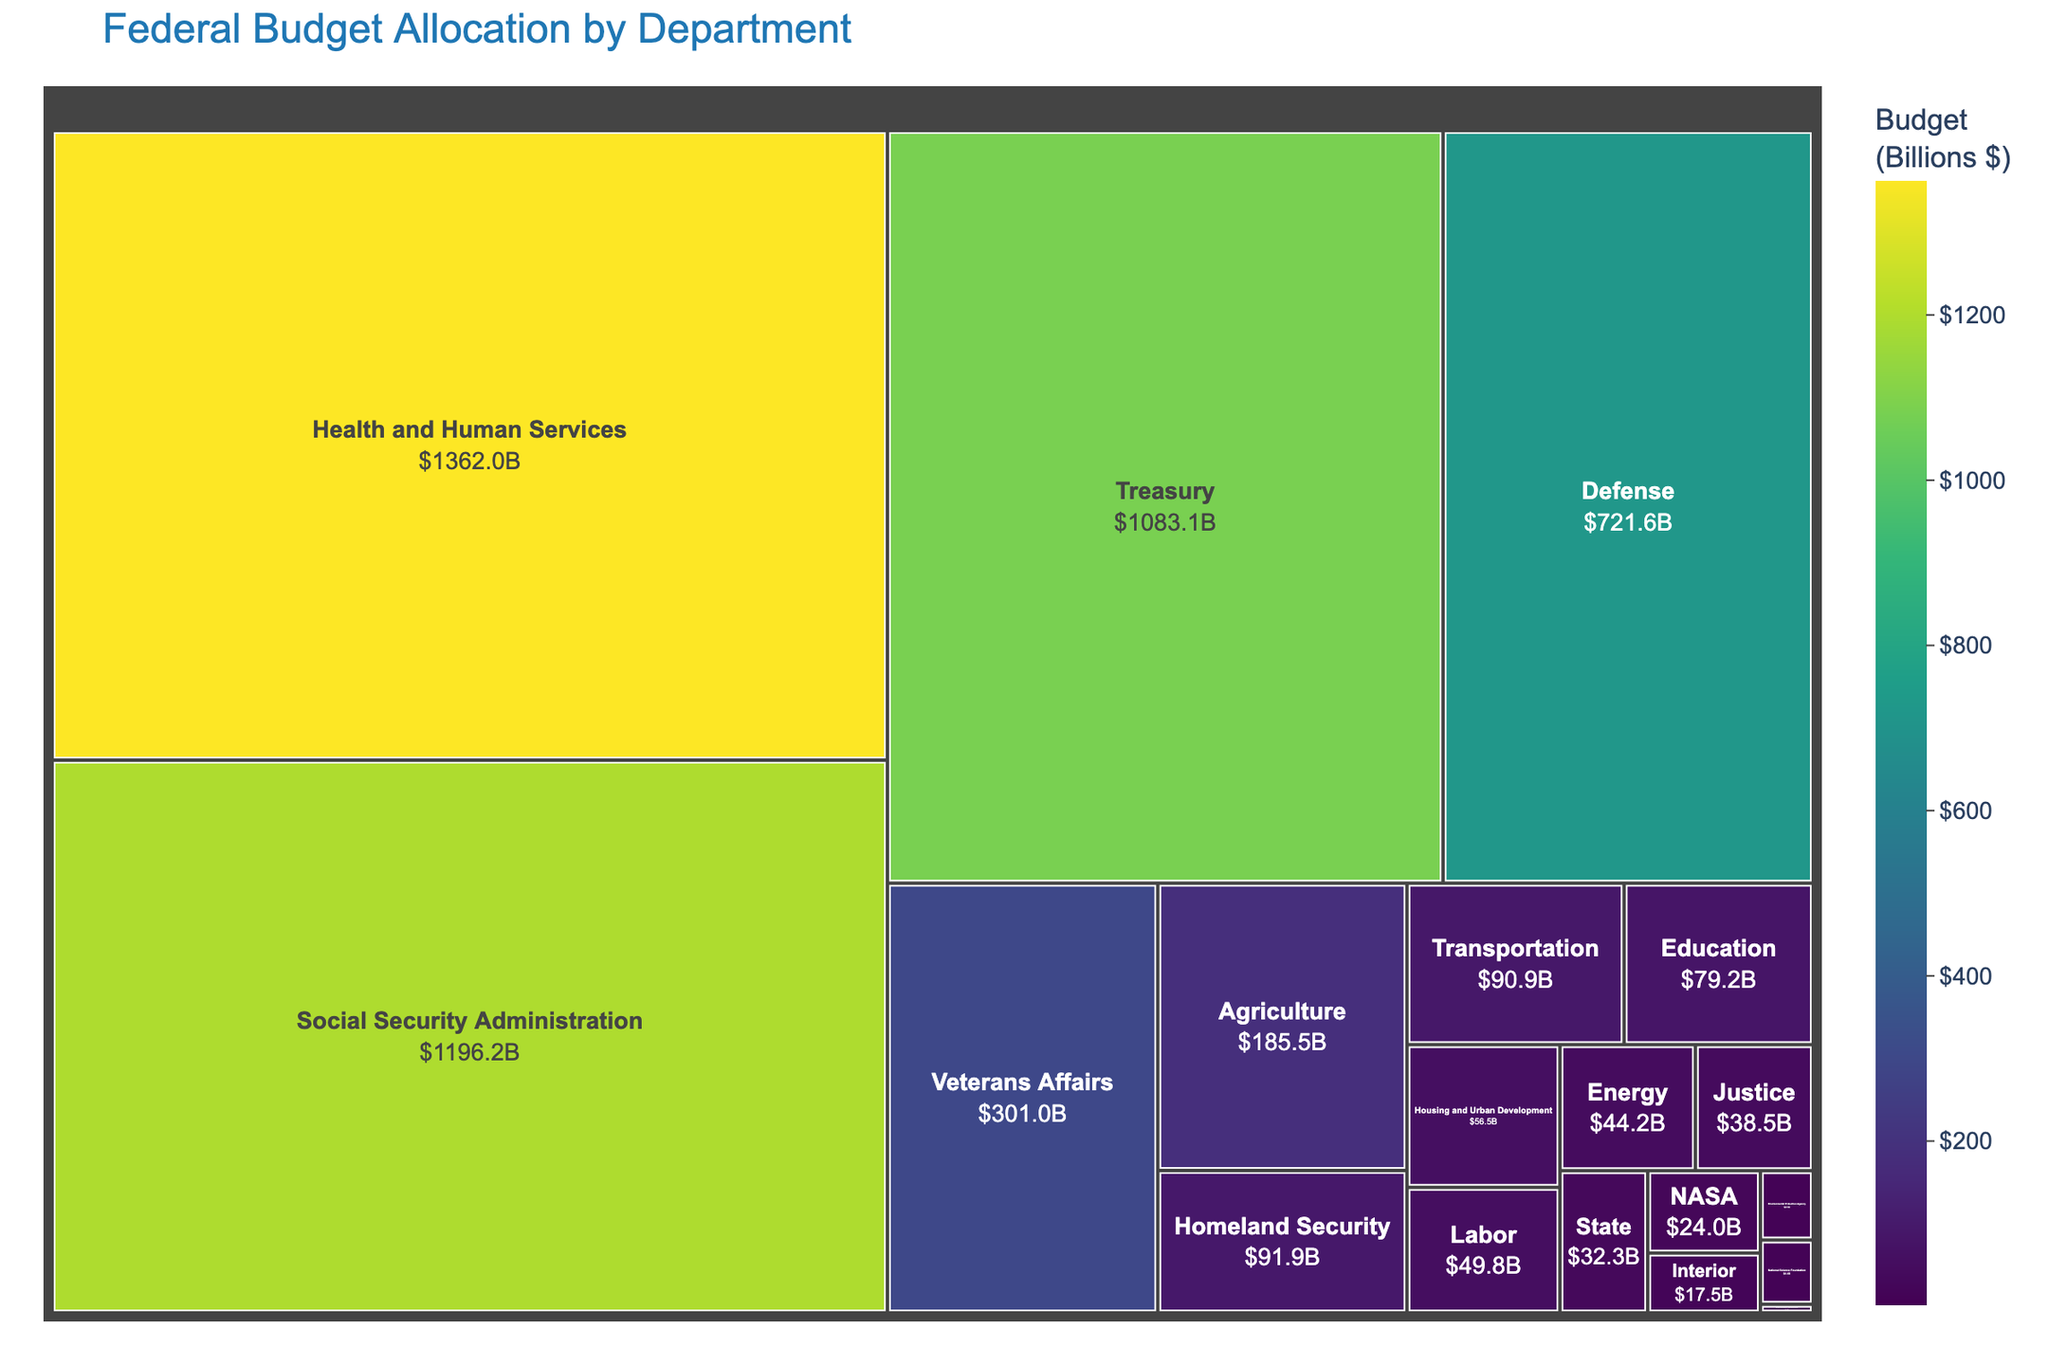What is the title of the treemap? The title of the treemap is prominently displayed at the top of the figure, summarizing what the treemap represents.
Answer: Federal Budget Allocation by Department Which department has the largest budget allocation? By visually comparing the sizes of the rectangles in the treemap, the largest portion corresponds to the "Health and Human Services" department.
Answer: Health and Human Services What is the total budget allocation for the Defense and the Veterans Affairs departments combined? The budget for Defense is $721.6 Billion, and for Veterans Affairs, it is $301.0 Billion. Summing these values gives 721.6 + 301.0 = $1,022.6 Billion.
Answer: $1,022.6 Billion Which department has a budget just under $100 billion? By examining the labels on the treemap and focusing on budgets around the $100 billion mark, the Transportation department fits this criterion with a budget of $90.9 Billion.
Answer: Transportation How does the budget for the Department of Education compare to the budget for the Department of Agriculture? The Department of Education has a budget of $79.2 Billion, while the Department of Agriculture has a budget of $185.5 Billion. Comparing these values, the Agriculture Department's budget is greater.
Answer: Agriculture's budget is greater What is the relative size comparison between the budgets of the Treasury and the Social Security Administration? The Treasury has a budget of $1,083.1 Billion, and the Social Security Administration has a budget of $1,196.2 Billion. The Social Security Administration's budget is larger.
Answer: Social Security Administration's budget is larger What are the combined budgets for the Justice and State departments? The budget for the Justice Department is $38.5 Billion, and for the State Department, it is $32.3 Billion. Combining these values gives 38.5 + 32.3 = $70.8 Billion.
Answer: $70.8 Billion Which department has the smallest budget allocation? By identifying the smallest rectangle in the treemap, the Small Business Administration has the smallest budget at $1.2 Billion.
Answer: Small Business Administration What is the difference between the budgets of Homeland Security and the Interior departments? The Homeland Security budget is $91.9 Billion, and the Interior Department's budget is $17.5 Billion. The difference is 91.9 - 17.5 = $74.4 Billion.
Answer: $74.4 Billion How do the budgets of NASA and the Environmental Protection Agency compare? NASA has a budget of $24.0 Billion, and the Environmental Protection Agency has a budget of $9.5 Billion. NASA's budget is larger.
Answer: NASA's budget is larger 